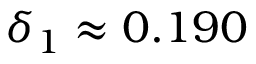Convert formula to latex. <formula><loc_0><loc_0><loc_500><loc_500>\delta _ { 1 } \approx 0 . 1 9 0</formula> 